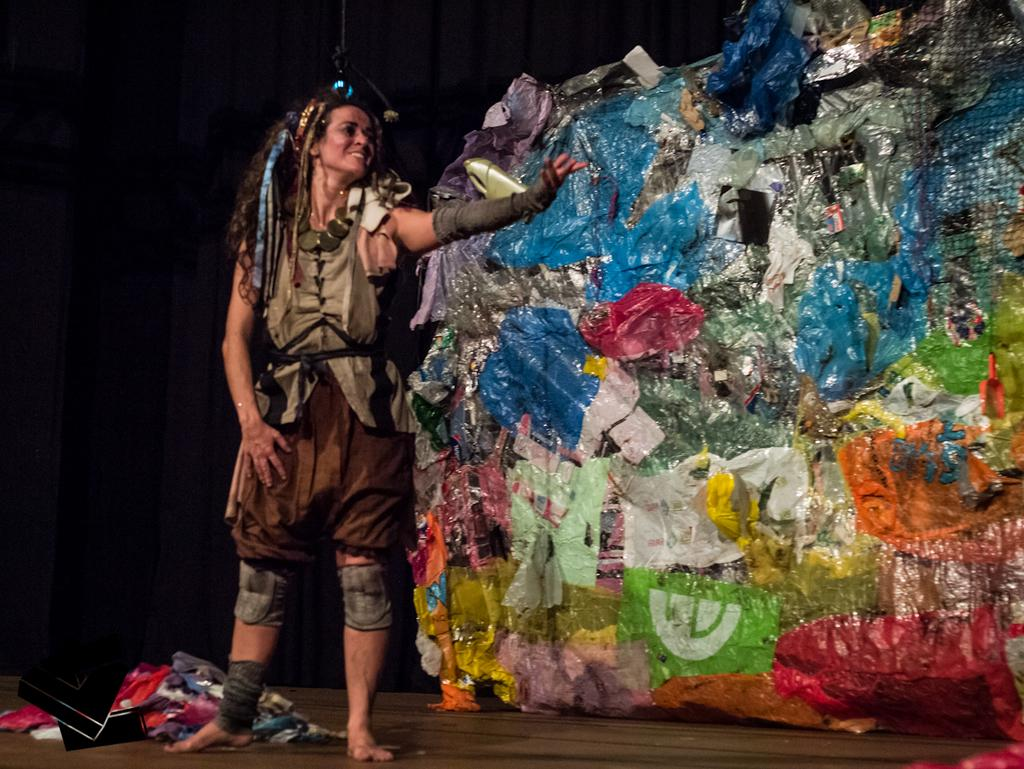Who is present in the image? There is a woman standing in the image. What is the woman doing in the image? The woman is smiling in the image. What is the artwork made of in the image? The artwork appears to be made of garbage materials. What else can be seen on the floor in the image? There are clothes lying on the floor in the image. Can you see any islands or oceans in the image? No, there are no islands or oceans present in the image. 